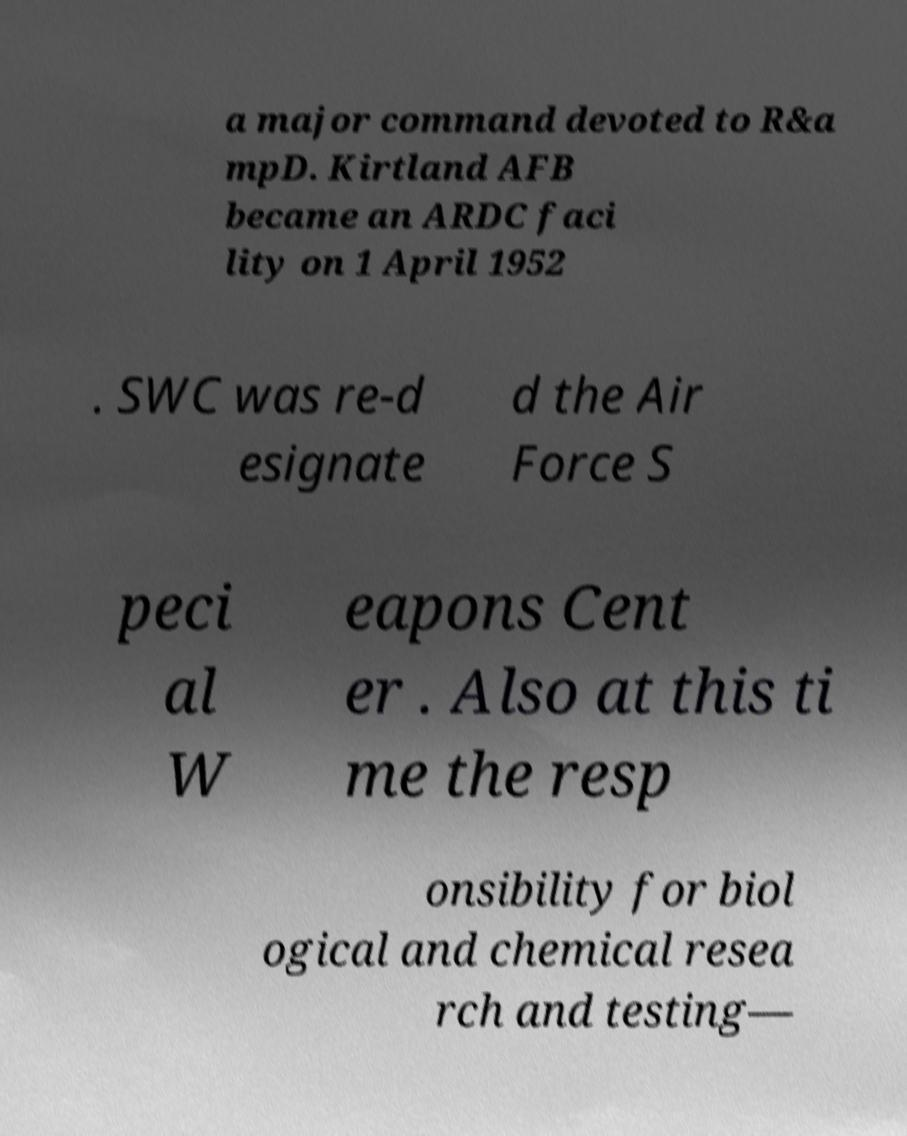Could you extract and type out the text from this image? a major command devoted to R&a mpD. Kirtland AFB became an ARDC faci lity on 1 April 1952 . SWC was re-d esignate d the Air Force S peci al W eapons Cent er . Also at this ti me the resp onsibility for biol ogical and chemical resea rch and testing— 